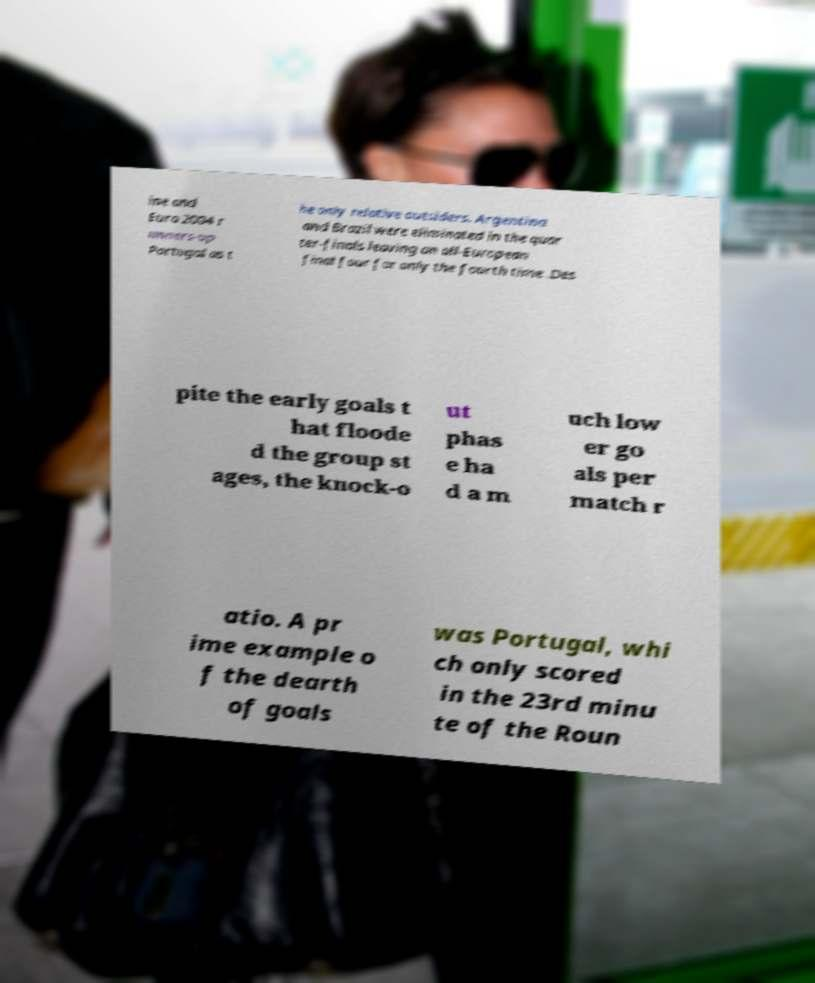Please identify and transcribe the text found in this image. ine and Euro 2004 r unners-up Portugal as t he only relative outsiders. Argentina and Brazil were eliminated in the quar ter-finals leaving an all-European final four for only the fourth time .Des pite the early goals t hat floode d the group st ages, the knock-o ut phas e ha d a m uch low er go als per match r atio. A pr ime example o f the dearth of goals was Portugal, whi ch only scored in the 23rd minu te of the Roun 